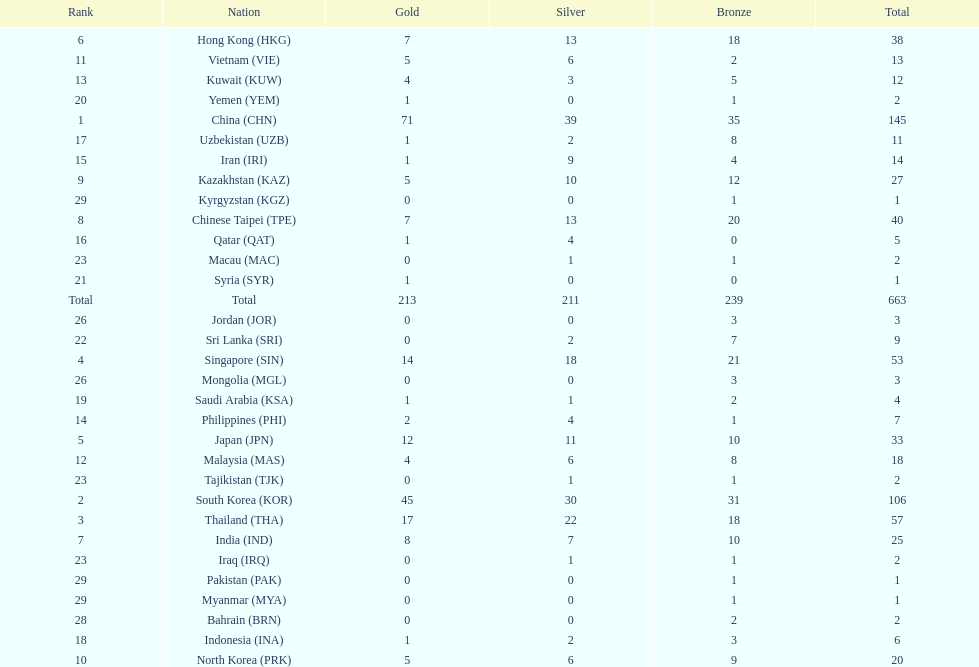What is the difference between the total amount of medals won by qatar and indonesia? 1. 